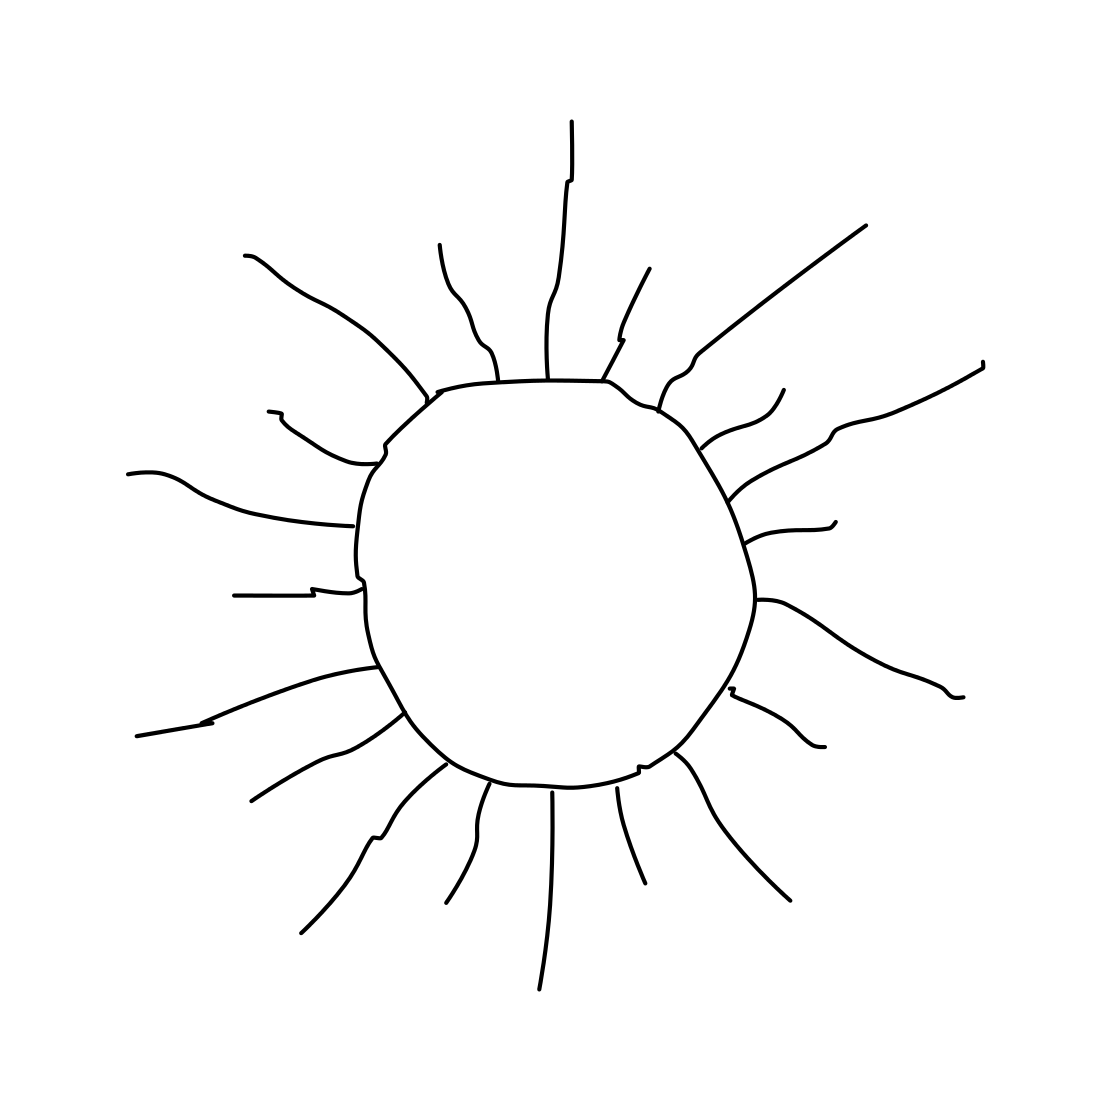Is there anything missing from this scene that you would expect to accompany an image of the sun? Typically, one might expect to see additional elements such as a sky, clouds, or a landscape to provide context for the sun, but this image focuses solely on the sun and its rays for a minimalist representation. 